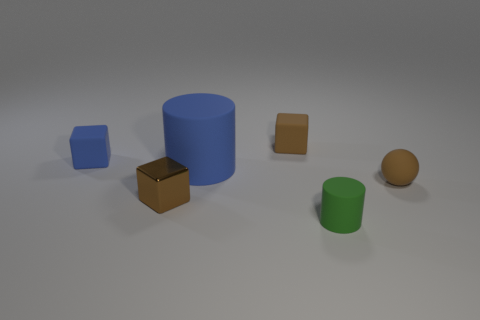How many other objects are there of the same shape as the tiny metal thing?
Your response must be concise. 2. Are the big blue cylinder and the green object made of the same material?
Your answer should be compact. Yes. What is the material of the brown thing that is left of the brown rubber sphere and in front of the blue cube?
Keep it short and to the point. Metal. There is a rubber cylinder that is on the left side of the green matte object; what color is it?
Provide a succinct answer. Blue. Is the number of brown metallic objects behind the tiny sphere greater than the number of gray things?
Offer a terse response. No. What number of other objects are the same size as the blue cylinder?
Give a very brief answer. 0. There is a small blue thing; what number of small matte cubes are on the left side of it?
Offer a terse response. 0. Are there an equal number of small green things that are behind the brown matte ball and blue objects in front of the tiny green cylinder?
Offer a terse response. Yes. What is the size of the brown matte object that is the same shape as the brown metallic object?
Ensure brevity in your answer.  Small. What is the shape of the thing that is in front of the brown shiny thing?
Provide a short and direct response. Cylinder. 